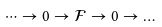Convert formula to latex. <formula><loc_0><loc_0><loc_500><loc_500>\dots \to 0 \to \mathcal { F } \to 0 \to \dots</formula> 